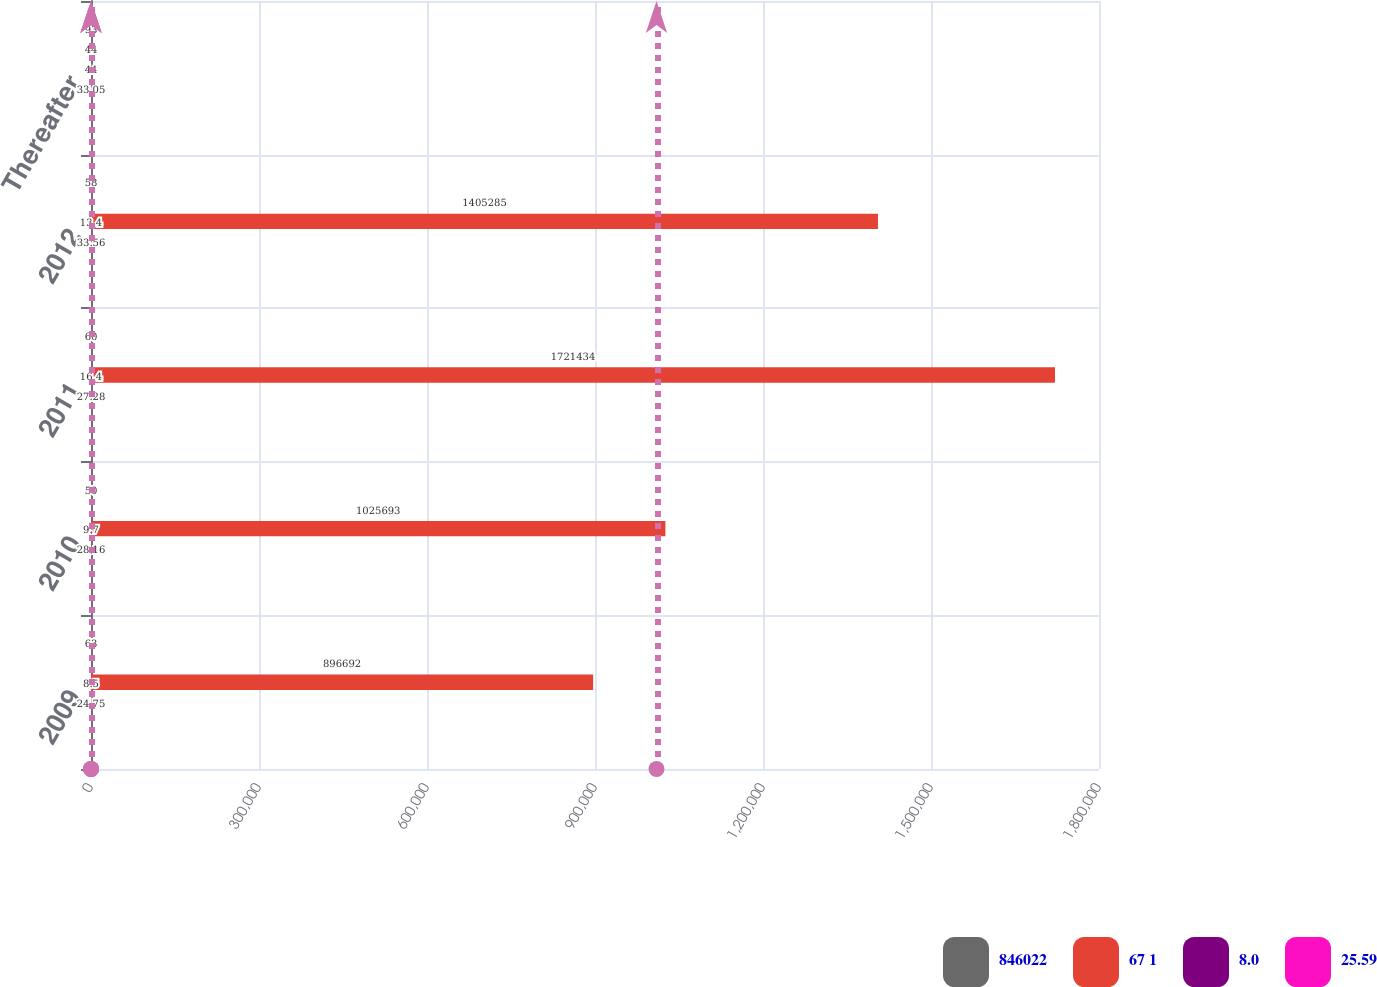Convert chart. <chart><loc_0><loc_0><loc_500><loc_500><stacked_bar_chart><ecel><fcel>2009<fcel>2010<fcel>2011<fcel>2012<fcel>Thereafter<nl><fcel>846022<fcel>63<fcel>50<fcel>60<fcel>58<fcel>93<nl><fcel>67 1<fcel>896692<fcel>1.02569e+06<fcel>1.72143e+06<fcel>1.40528e+06<fcel>44<nl><fcel>8.0<fcel>8.5<fcel>9.7<fcel>16.4<fcel>13.4<fcel>44<nl><fcel>25.59<fcel>24.75<fcel>28.16<fcel>27.28<fcel>33.56<fcel>33.05<nl></chart> 